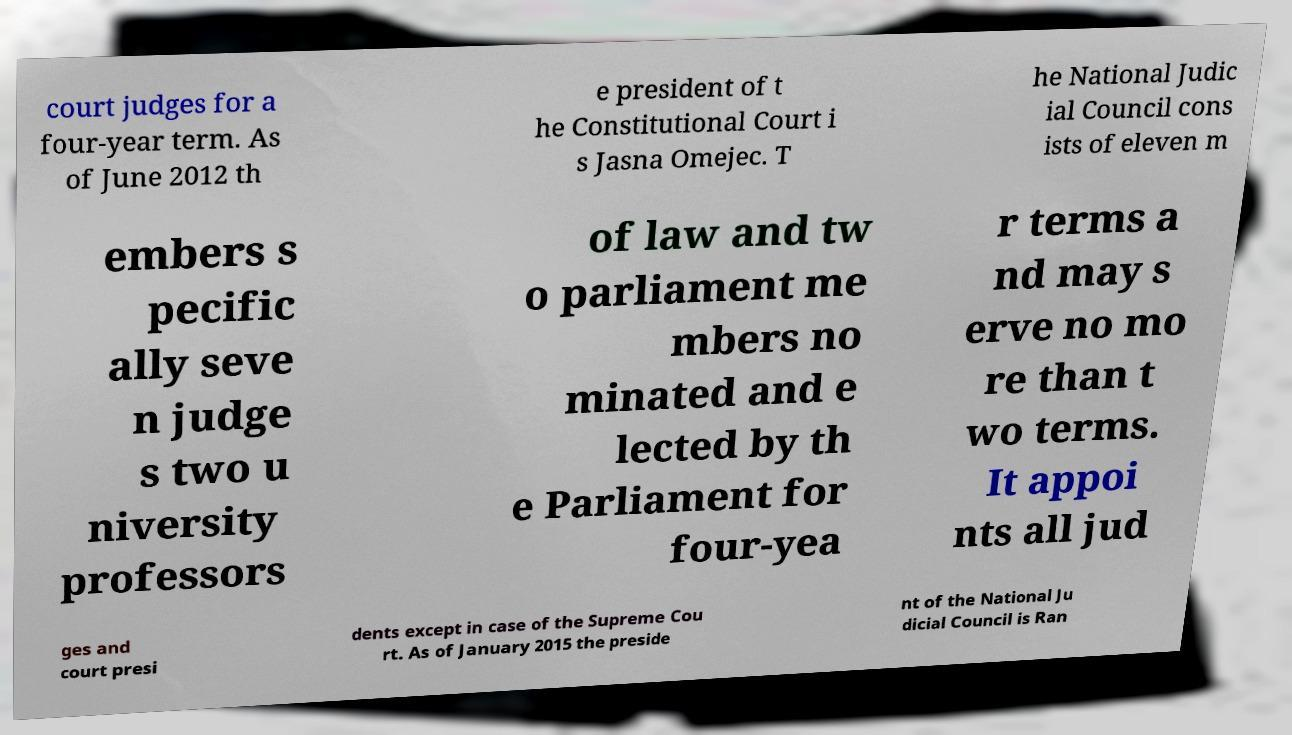For documentation purposes, I need the text within this image transcribed. Could you provide that? court judges for a four-year term. As of June 2012 th e president of t he Constitutional Court i s Jasna Omejec. T he National Judic ial Council cons ists of eleven m embers s pecific ally seve n judge s two u niversity professors of law and tw o parliament me mbers no minated and e lected by th e Parliament for four-yea r terms a nd may s erve no mo re than t wo terms. It appoi nts all jud ges and court presi dents except in case of the Supreme Cou rt. As of January 2015 the preside nt of the National Ju dicial Council is Ran 